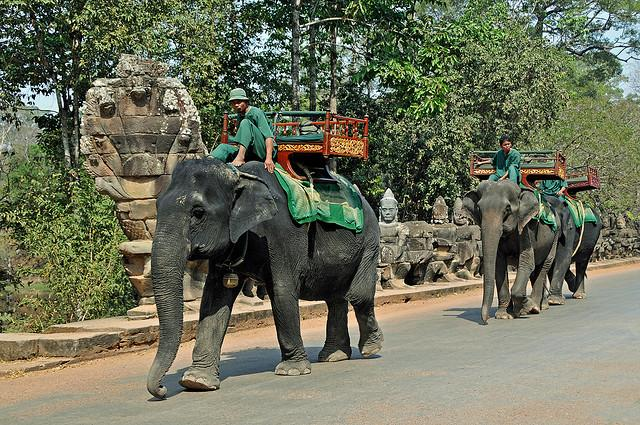Which country is famous for elephants? Please explain your reasoning. thailand. Thailand has a lot of elephants. 